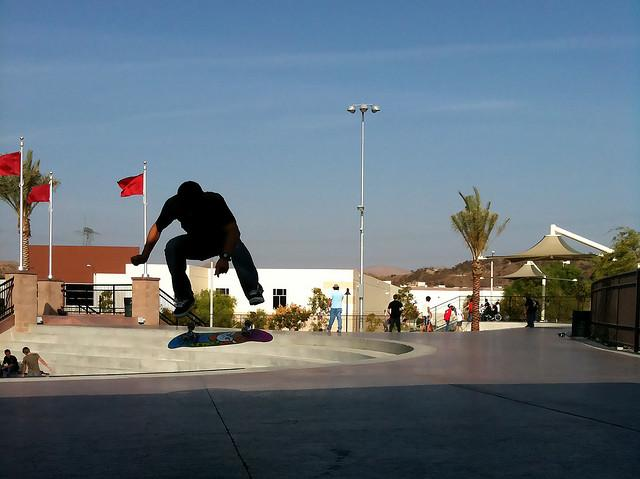What action is he taking with the board? jumping 